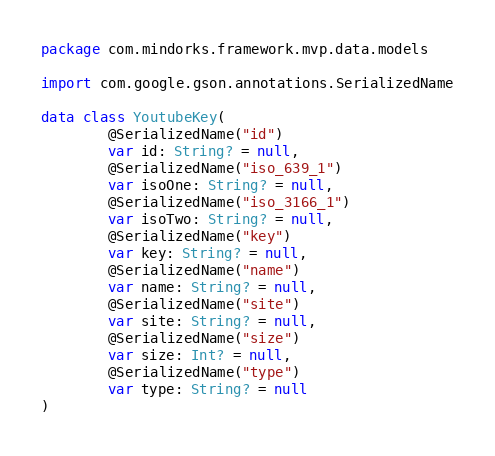Convert code to text. <code><loc_0><loc_0><loc_500><loc_500><_Kotlin_>package com.mindorks.framework.mvp.data.models

import com.google.gson.annotations.SerializedName

data class YoutubeKey(
        @SerializedName("id")
        var id: String? = null,
        @SerializedName("iso_639_1")
        var isoOne: String? = null,
        @SerializedName("iso_3166_1")
        var isoTwo: String? = null,
        @SerializedName("key")
        var key: String? = null,
        @SerializedName("name")
        var name: String? = null,
        @SerializedName("site")
        var site: String? = null,
        @SerializedName("size")
        var size: Int? = null,
        @SerializedName("type")
        var type: String? = null
)</code> 